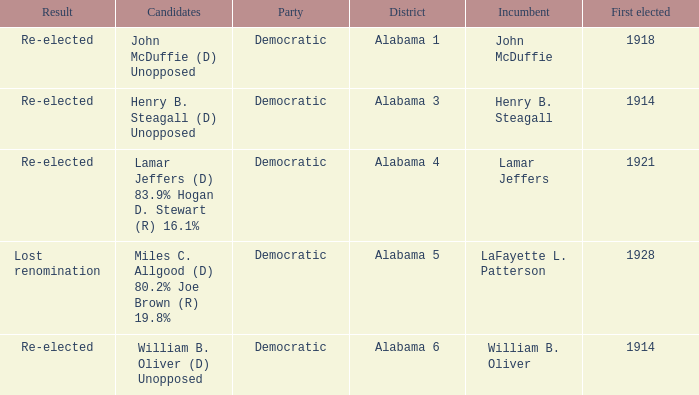How many in lost renomination results were elected first? 1928.0. 